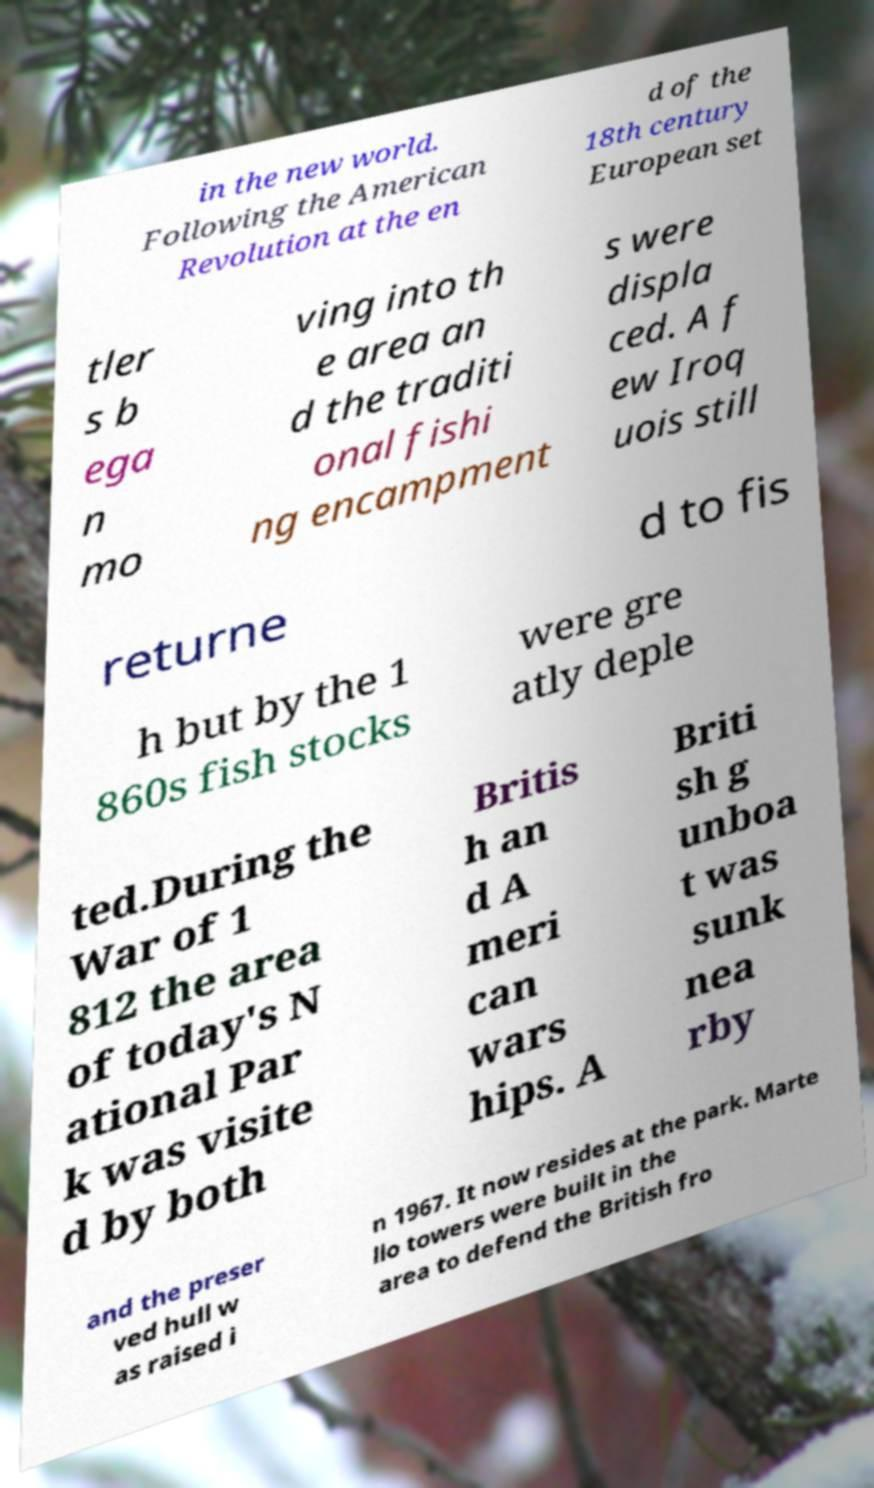Please identify and transcribe the text found in this image. in the new world. Following the American Revolution at the en d of the 18th century European set tler s b ega n mo ving into th e area an d the traditi onal fishi ng encampment s were displa ced. A f ew Iroq uois still returne d to fis h but by the 1 860s fish stocks were gre atly deple ted.During the War of 1 812 the area of today's N ational Par k was visite d by both Britis h an d A meri can wars hips. A Briti sh g unboa t was sunk nea rby and the preser ved hull w as raised i n 1967. It now resides at the park. Marte llo towers were built in the area to defend the British fro 